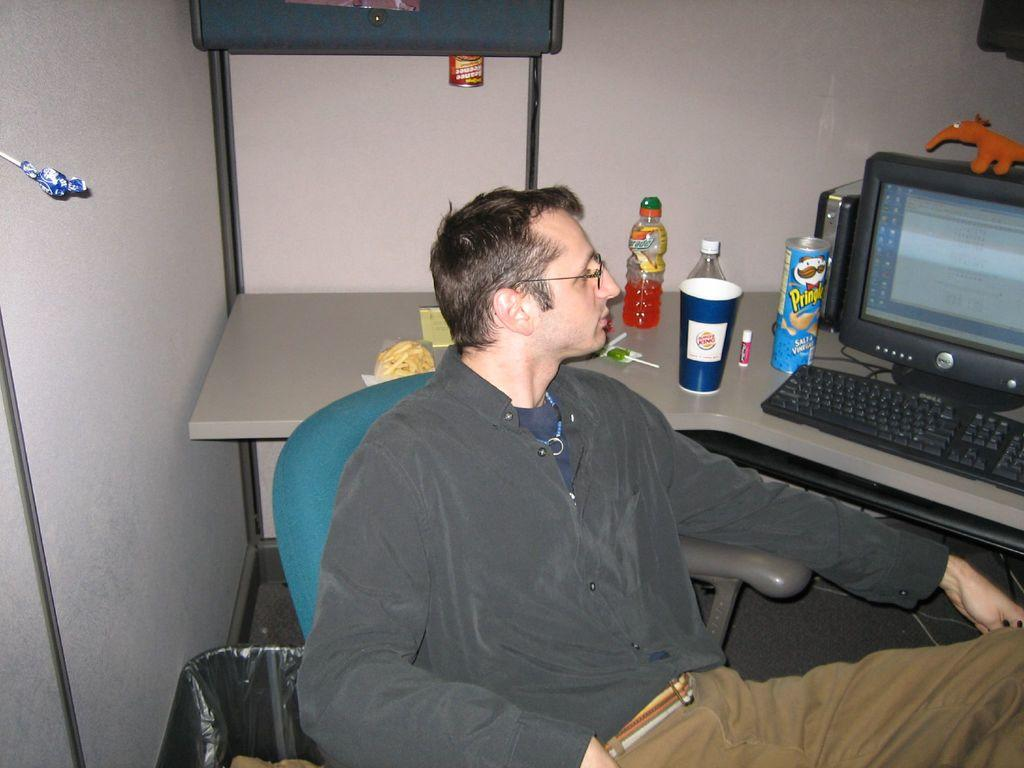Provide a one-sentence caption for the provided image. A man is sitting at a desk with a blue pringles container in front of him. 